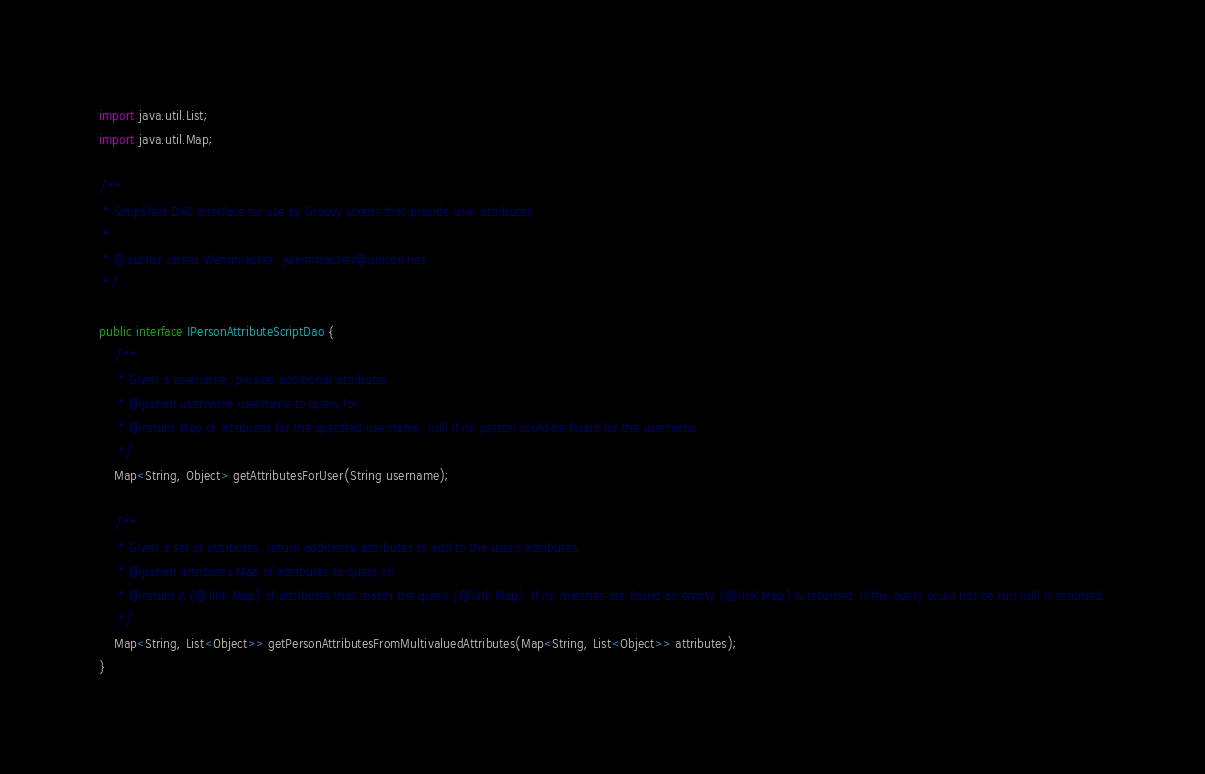Convert code to text. <code><loc_0><loc_0><loc_500><loc_500><_Java_>import java.util.List;
import java.util.Map;

/**
 * Simplified DAO interface for use by Groovy scripts that provide user attributes.
 *
 * @author James Wennmacher, jwennmacher@unicon.net
 */

public interface IPersonAttributeScriptDao {
    /**
     * Given a username, provide additional attributes.
     * @param username username to query for
     * @return Map of attributes for the specified username, null if no person could be found for the username.
     */
    Map<String, Object> getAttributesForUser(String username);

    /**
     * Given a set of attributes, return additional attributes to add to the user's attributes.
     * @param attributes Map of attributes to query on
     * @return A {@link Map} of attributes that match the query {@link Map}. If no matches are found an empty {@link Map} is returned. If the query could not be run null is returned.
     */
    Map<String, List<Object>> getPersonAttributesFromMultivaluedAttributes(Map<String, List<Object>> attributes);
}
</code> 